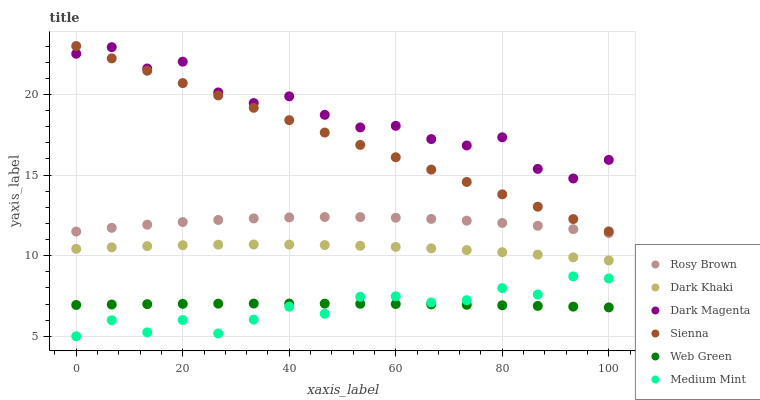Does Medium Mint have the minimum area under the curve?
Answer yes or no. Yes. Does Dark Magenta have the maximum area under the curve?
Answer yes or no. Yes. Does Sienna have the minimum area under the curve?
Answer yes or no. No. Does Sienna have the maximum area under the curve?
Answer yes or no. No. Is Sienna the smoothest?
Answer yes or no. Yes. Is Dark Magenta the roughest?
Answer yes or no. Yes. Is Dark Magenta the smoothest?
Answer yes or no. No. Is Sienna the roughest?
Answer yes or no. No. Does Medium Mint have the lowest value?
Answer yes or no. Yes. Does Sienna have the lowest value?
Answer yes or no. No. Does Sienna have the highest value?
Answer yes or no. Yes. Does Dark Magenta have the highest value?
Answer yes or no. No. Is Medium Mint less than Rosy Brown?
Answer yes or no. Yes. Is Dark Khaki greater than Web Green?
Answer yes or no. Yes. Does Dark Magenta intersect Sienna?
Answer yes or no. Yes. Is Dark Magenta less than Sienna?
Answer yes or no. No. Is Dark Magenta greater than Sienna?
Answer yes or no. No. Does Medium Mint intersect Rosy Brown?
Answer yes or no. No. 